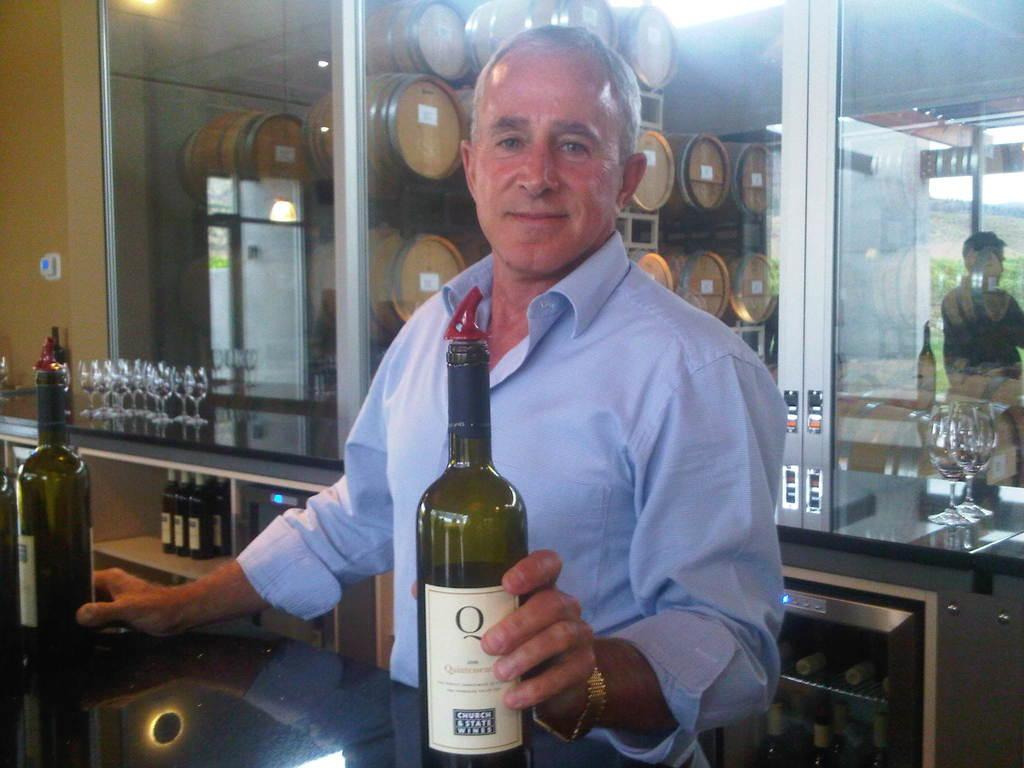<image>
Give a short and clear explanation of the subsequent image. A man holds a bottle with the letter O on the label. 